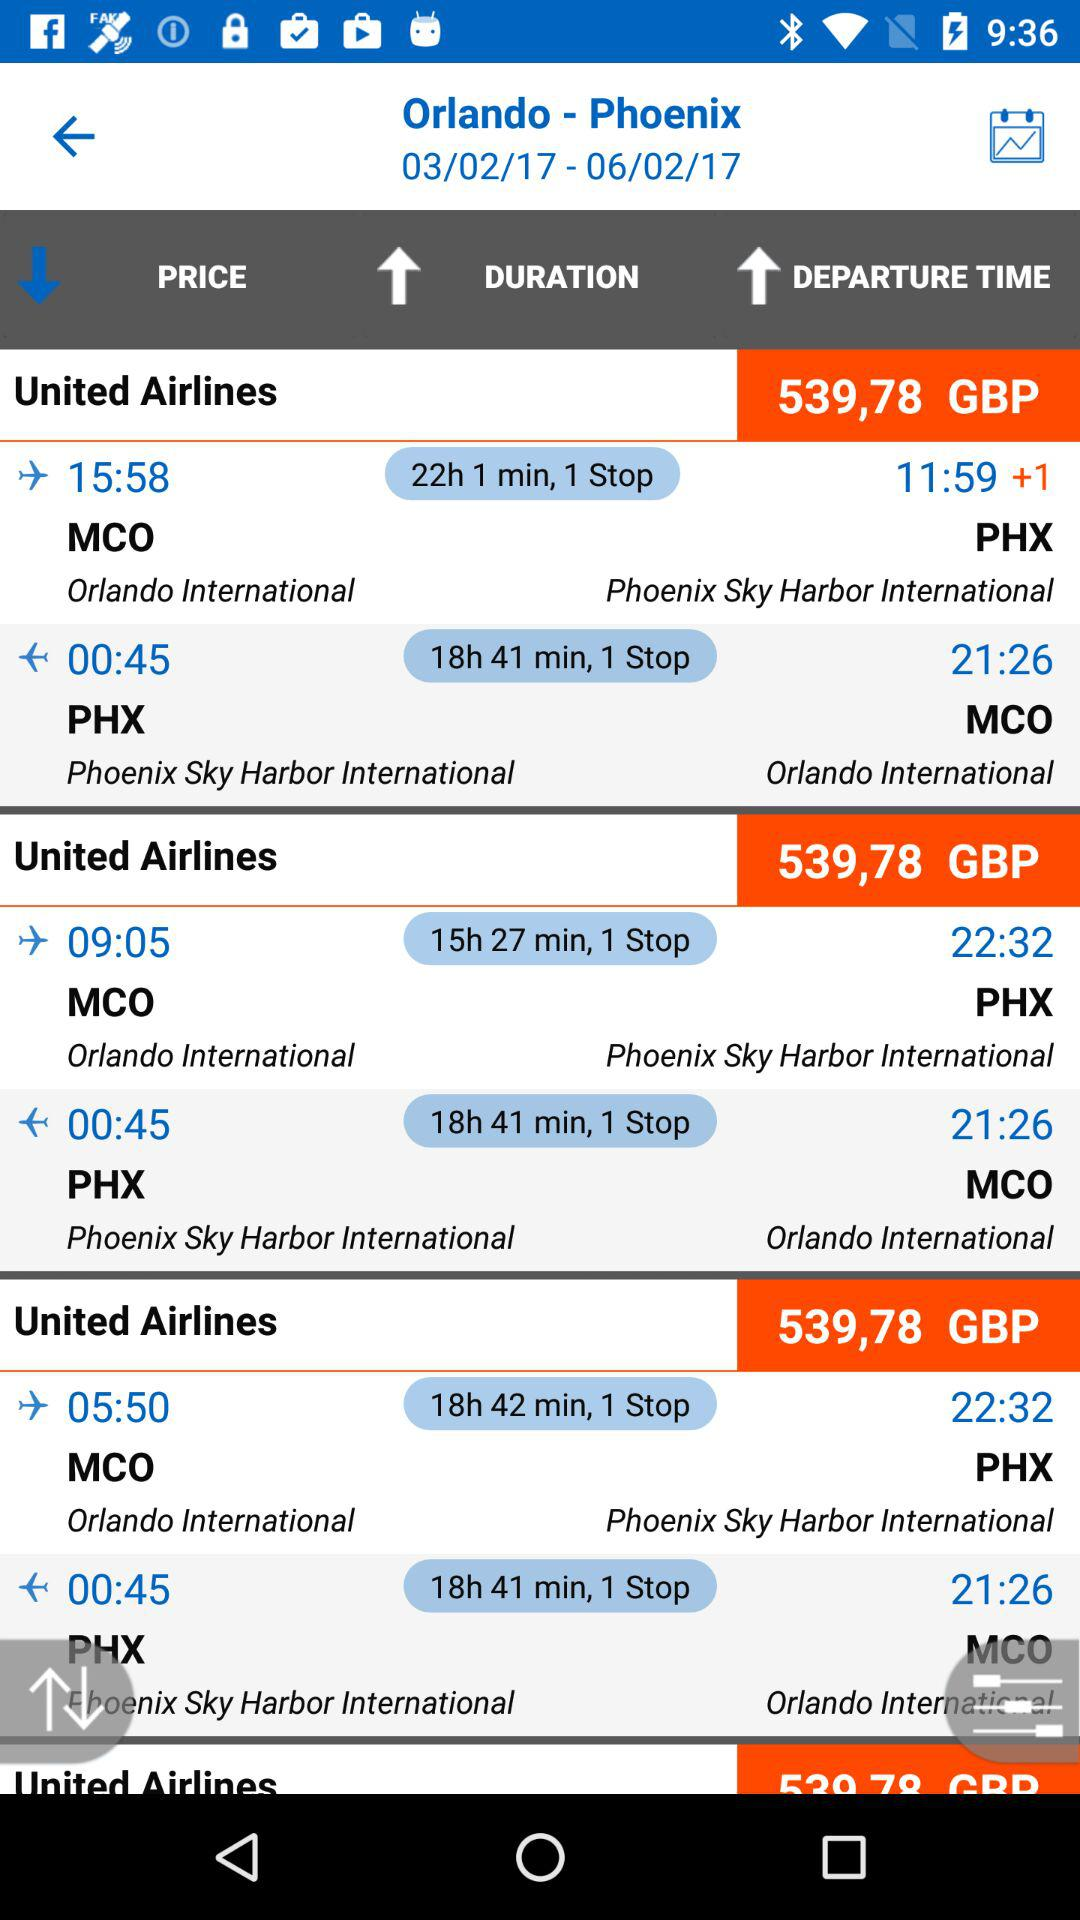What is the departure time of the flight from MCO to PHX with a duration of 22 hours, 1 minute? The departure time of the flight is 15:58. 